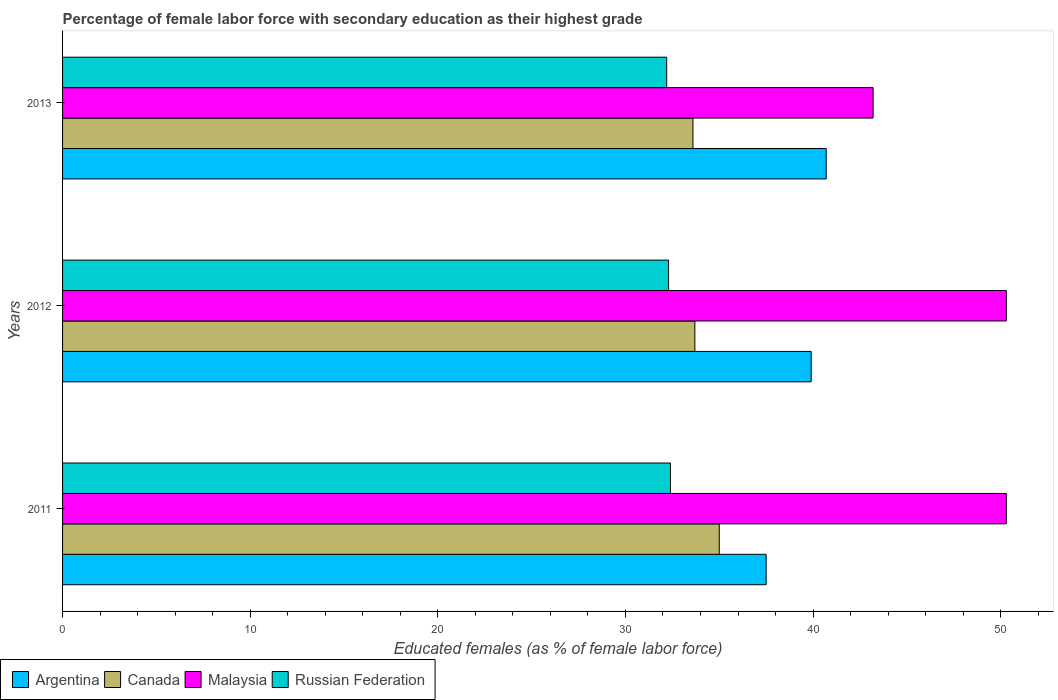How many different coloured bars are there?
Provide a succinct answer. 4. How many groups of bars are there?
Your answer should be very brief. 3. How many bars are there on the 1st tick from the top?
Make the answer very short. 4. What is the percentage of female labor force with secondary education in Russian Federation in 2012?
Provide a short and direct response. 32.3. Across all years, what is the maximum percentage of female labor force with secondary education in Malaysia?
Provide a short and direct response. 50.3. Across all years, what is the minimum percentage of female labor force with secondary education in Russian Federation?
Give a very brief answer. 32.2. In which year was the percentage of female labor force with secondary education in Russian Federation maximum?
Make the answer very short. 2011. What is the total percentage of female labor force with secondary education in Argentina in the graph?
Provide a succinct answer. 118.1. What is the difference between the percentage of female labor force with secondary education in Canada in 2011 and that in 2012?
Make the answer very short. 1.3. What is the difference between the percentage of female labor force with secondary education in Argentina in 2013 and the percentage of female labor force with secondary education in Malaysia in 2012?
Your answer should be compact. -9.6. What is the average percentage of female labor force with secondary education in Malaysia per year?
Your answer should be very brief. 47.93. In the year 2013, what is the difference between the percentage of female labor force with secondary education in Argentina and percentage of female labor force with secondary education in Russian Federation?
Your response must be concise. 8.5. In how many years, is the percentage of female labor force with secondary education in Russian Federation greater than 34 %?
Offer a terse response. 0. What is the ratio of the percentage of female labor force with secondary education in Malaysia in 2011 to that in 2013?
Ensure brevity in your answer.  1.16. Is the difference between the percentage of female labor force with secondary education in Argentina in 2012 and 2013 greater than the difference between the percentage of female labor force with secondary education in Russian Federation in 2012 and 2013?
Give a very brief answer. No. What is the difference between the highest and the second highest percentage of female labor force with secondary education in Argentina?
Give a very brief answer. 0.8. What is the difference between the highest and the lowest percentage of female labor force with secondary education in Canada?
Your response must be concise. 1.4. In how many years, is the percentage of female labor force with secondary education in Russian Federation greater than the average percentage of female labor force with secondary education in Russian Federation taken over all years?
Offer a very short reply. 1. Is the sum of the percentage of female labor force with secondary education in Canada in 2011 and 2012 greater than the maximum percentage of female labor force with secondary education in Argentina across all years?
Provide a succinct answer. Yes. What does the 1st bar from the top in 2011 represents?
Make the answer very short. Russian Federation. Is it the case that in every year, the sum of the percentage of female labor force with secondary education in Russian Federation and percentage of female labor force with secondary education in Malaysia is greater than the percentage of female labor force with secondary education in Argentina?
Ensure brevity in your answer.  Yes. How many bars are there?
Make the answer very short. 12. How many years are there in the graph?
Make the answer very short. 3. Does the graph contain any zero values?
Keep it short and to the point. No. Where does the legend appear in the graph?
Give a very brief answer. Bottom left. How are the legend labels stacked?
Your response must be concise. Horizontal. What is the title of the graph?
Provide a succinct answer. Percentage of female labor force with secondary education as their highest grade. What is the label or title of the X-axis?
Ensure brevity in your answer.  Educated females (as % of female labor force). What is the label or title of the Y-axis?
Offer a very short reply. Years. What is the Educated females (as % of female labor force) of Argentina in 2011?
Keep it short and to the point. 37.5. What is the Educated females (as % of female labor force) of Canada in 2011?
Provide a short and direct response. 35. What is the Educated females (as % of female labor force) in Malaysia in 2011?
Ensure brevity in your answer.  50.3. What is the Educated females (as % of female labor force) in Russian Federation in 2011?
Your answer should be very brief. 32.4. What is the Educated females (as % of female labor force) of Argentina in 2012?
Ensure brevity in your answer.  39.9. What is the Educated females (as % of female labor force) of Canada in 2012?
Make the answer very short. 33.7. What is the Educated females (as % of female labor force) in Malaysia in 2012?
Ensure brevity in your answer.  50.3. What is the Educated females (as % of female labor force) in Russian Federation in 2012?
Your response must be concise. 32.3. What is the Educated females (as % of female labor force) in Argentina in 2013?
Provide a short and direct response. 40.7. What is the Educated females (as % of female labor force) of Canada in 2013?
Offer a very short reply. 33.6. What is the Educated females (as % of female labor force) of Malaysia in 2013?
Provide a short and direct response. 43.2. What is the Educated females (as % of female labor force) in Russian Federation in 2013?
Give a very brief answer. 32.2. Across all years, what is the maximum Educated females (as % of female labor force) in Argentina?
Your answer should be compact. 40.7. Across all years, what is the maximum Educated females (as % of female labor force) in Malaysia?
Offer a very short reply. 50.3. Across all years, what is the maximum Educated females (as % of female labor force) of Russian Federation?
Give a very brief answer. 32.4. Across all years, what is the minimum Educated females (as % of female labor force) of Argentina?
Your answer should be compact. 37.5. Across all years, what is the minimum Educated females (as % of female labor force) of Canada?
Your answer should be very brief. 33.6. Across all years, what is the minimum Educated females (as % of female labor force) of Malaysia?
Provide a succinct answer. 43.2. Across all years, what is the minimum Educated females (as % of female labor force) in Russian Federation?
Offer a very short reply. 32.2. What is the total Educated females (as % of female labor force) of Argentina in the graph?
Provide a succinct answer. 118.1. What is the total Educated females (as % of female labor force) in Canada in the graph?
Your answer should be compact. 102.3. What is the total Educated females (as % of female labor force) of Malaysia in the graph?
Keep it short and to the point. 143.8. What is the total Educated females (as % of female labor force) in Russian Federation in the graph?
Give a very brief answer. 96.9. What is the difference between the Educated females (as % of female labor force) in Argentina in 2011 and that in 2012?
Make the answer very short. -2.4. What is the difference between the Educated females (as % of female labor force) in Malaysia in 2011 and that in 2013?
Your answer should be very brief. 7.1. What is the difference between the Educated females (as % of female labor force) in Canada in 2012 and that in 2013?
Offer a terse response. 0.1. What is the difference between the Educated females (as % of female labor force) in Malaysia in 2012 and that in 2013?
Offer a very short reply. 7.1. What is the difference between the Educated females (as % of female labor force) of Argentina in 2011 and the Educated females (as % of female labor force) of Canada in 2012?
Provide a short and direct response. 3.8. What is the difference between the Educated females (as % of female labor force) in Canada in 2011 and the Educated females (as % of female labor force) in Malaysia in 2012?
Provide a short and direct response. -15.3. What is the difference between the Educated females (as % of female labor force) in Malaysia in 2011 and the Educated females (as % of female labor force) in Russian Federation in 2012?
Your answer should be very brief. 18. What is the difference between the Educated females (as % of female labor force) in Argentina in 2011 and the Educated females (as % of female labor force) in Canada in 2013?
Provide a succinct answer. 3.9. What is the difference between the Educated females (as % of female labor force) of Argentina in 2011 and the Educated females (as % of female labor force) of Russian Federation in 2013?
Make the answer very short. 5.3. What is the difference between the Educated females (as % of female labor force) of Malaysia in 2011 and the Educated females (as % of female labor force) of Russian Federation in 2013?
Keep it short and to the point. 18.1. What is the difference between the Educated females (as % of female labor force) in Argentina in 2012 and the Educated females (as % of female labor force) in Malaysia in 2013?
Make the answer very short. -3.3. What is the difference between the Educated females (as % of female labor force) of Malaysia in 2012 and the Educated females (as % of female labor force) of Russian Federation in 2013?
Make the answer very short. 18.1. What is the average Educated females (as % of female labor force) of Argentina per year?
Keep it short and to the point. 39.37. What is the average Educated females (as % of female labor force) of Canada per year?
Make the answer very short. 34.1. What is the average Educated females (as % of female labor force) in Malaysia per year?
Make the answer very short. 47.93. What is the average Educated females (as % of female labor force) of Russian Federation per year?
Give a very brief answer. 32.3. In the year 2011, what is the difference between the Educated females (as % of female labor force) of Argentina and Educated females (as % of female labor force) of Canada?
Make the answer very short. 2.5. In the year 2011, what is the difference between the Educated females (as % of female labor force) in Canada and Educated females (as % of female labor force) in Malaysia?
Your response must be concise. -15.3. In the year 2012, what is the difference between the Educated females (as % of female labor force) in Canada and Educated females (as % of female labor force) in Malaysia?
Give a very brief answer. -16.6. In the year 2012, what is the difference between the Educated females (as % of female labor force) in Canada and Educated females (as % of female labor force) in Russian Federation?
Provide a short and direct response. 1.4. In the year 2013, what is the difference between the Educated females (as % of female labor force) in Argentina and Educated females (as % of female labor force) in Canada?
Your response must be concise. 7.1. In the year 2013, what is the difference between the Educated females (as % of female labor force) of Canada and Educated females (as % of female labor force) of Malaysia?
Make the answer very short. -9.6. In the year 2013, what is the difference between the Educated females (as % of female labor force) in Canada and Educated females (as % of female labor force) in Russian Federation?
Give a very brief answer. 1.4. What is the ratio of the Educated females (as % of female labor force) in Argentina in 2011 to that in 2012?
Ensure brevity in your answer.  0.94. What is the ratio of the Educated females (as % of female labor force) in Canada in 2011 to that in 2012?
Provide a short and direct response. 1.04. What is the ratio of the Educated females (as % of female labor force) in Malaysia in 2011 to that in 2012?
Ensure brevity in your answer.  1. What is the ratio of the Educated females (as % of female labor force) in Argentina in 2011 to that in 2013?
Your answer should be compact. 0.92. What is the ratio of the Educated females (as % of female labor force) of Canada in 2011 to that in 2013?
Your answer should be compact. 1.04. What is the ratio of the Educated females (as % of female labor force) of Malaysia in 2011 to that in 2013?
Offer a terse response. 1.16. What is the ratio of the Educated females (as % of female labor force) of Russian Federation in 2011 to that in 2013?
Offer a very short reply. 1.01. What is the ratio of the Educated females (as % of female labor force) of Argentina in 2012 to that in 2013?
Give a very brief answer. 0.98. What is the ratio of the Educated females (as % of female labor force) in Malaysia in 2012 to that in 2013?
Make the answer very short. 1.16. What is the ratio of the Educated females (as % of female labor force) in Russian Federation in 2012 to that in 2013?
Ensure brevity in your answer.  1. What is the difference between the highest and the second highest Educated females (as % of female labor force) in Canada?
Ensure brevity in your answer.  1.3. 